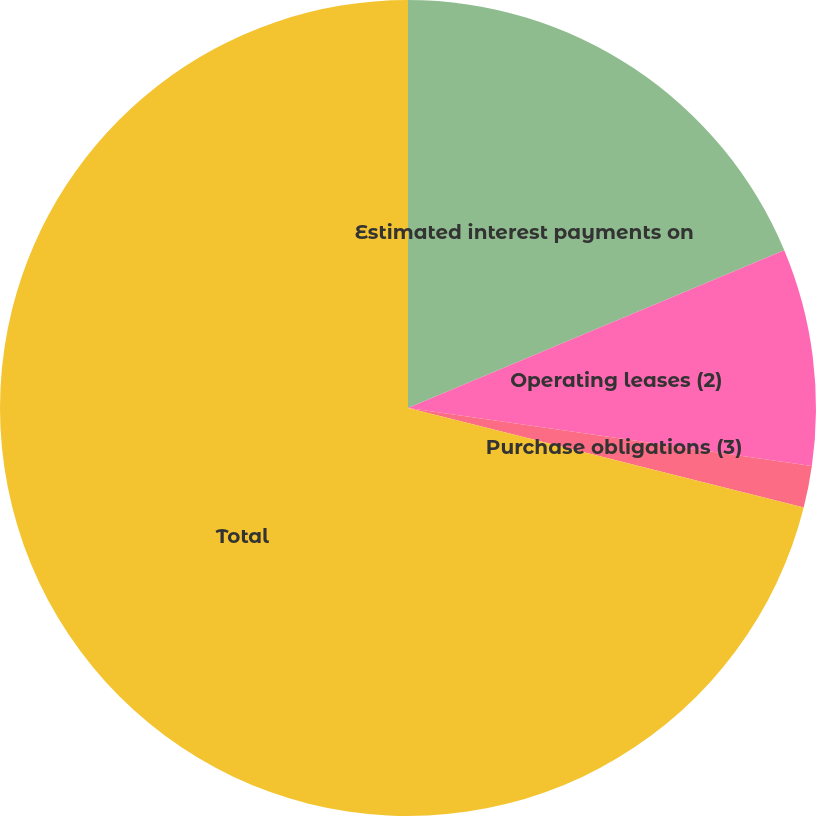Convert chart to OTSL. <chart><loc_0><loc_0><loc_500><loc_500><pie_chart><fcel>Estimated interest payments on<fcel>Operating leases (2)<fcel>Purchase obligations (3)<fcel>Total<nl><fcel>18.68%<fcel>8.59%<fcel>1.65%<fcel>71.09%<nl></chart> 